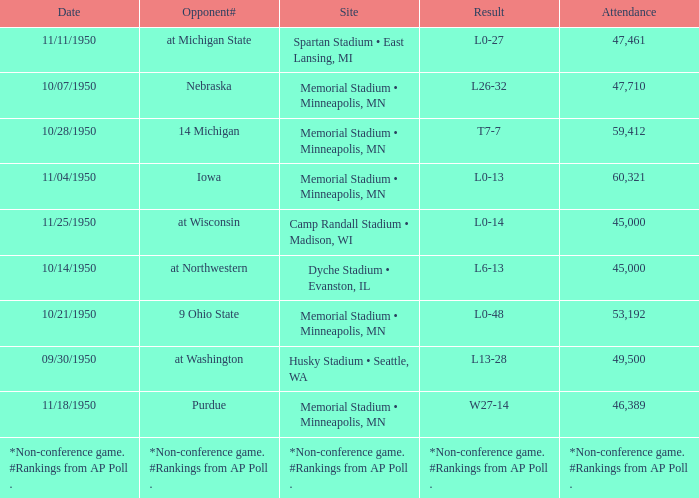What is the Site when the date is 11/11/1950? Spartan Stadium • East Lansing, MI. Would you be able to parse every entry in this table? {'header': ['Date', 'Opponent#', 'Site', 'Result', 'Attendance'], 'rows': [['11/11/1950', 'at Michigan State', 'Spartan Stadium • East Lansing, MI', 'L0-27', '47,461'], ['10/07/1950', 'Nebraska', 'Memorial Stadium • Minneapolis, MN', 'L26-32', '47,710'], ['10/28/1950', '14 Michigan', 'Memorial Stadium • Minneapolis, MN', 'T7-7', '59,412'], ['11/04/1950', 'Iowa', 'Memorial Stadium • Minneapolis, MN', 'L0-13', '60,321'], ['11/25/1950', 'at Wisconsin', 'Camp Randall Stadium • Madison, WI', 'L0-14', '45,000'], ['10/14/1950', 'at Northwestern', 'Dyche Stadium • Evanston, IL', 'L6-13', '45,000'], ['10/21/1950', '9 Ohio State', 'Memorial Stadium • Minneapolis, MN', 'L0-48', '53,192'], ['09/30/1950', 'at Washington', 'Husky Stadium • Seattle, WA', 'L13-28', '49,500'], ['11/18/1950', 'Purdue', 'Memorial Stadium • Minneapolis, MN', 'W27-14', '46,389'], ['*Non-conference game. #Rankings from AP Poll .', '*Non-conference game. #Rankings from AP Poll .', '*Non-conference game. #Rankings from AP Poll .', '*Non-conference game. #Rankings from AP Poll .', '*Non-conference game. #Rankings from AP Poll .']]} 